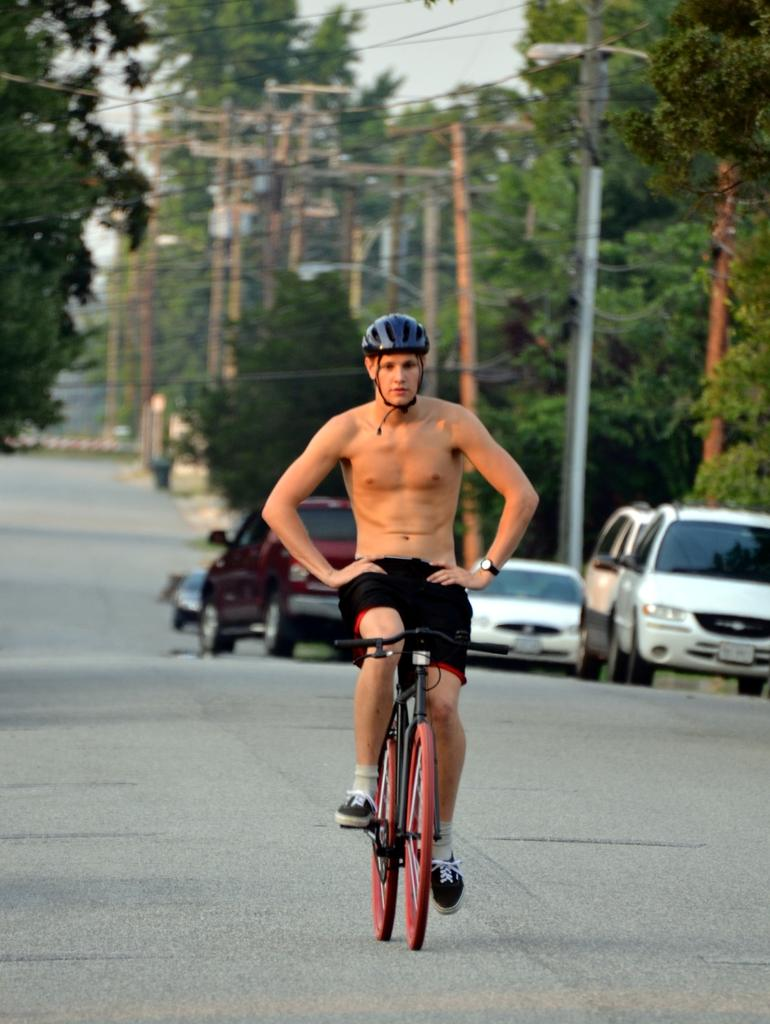What is the person in the image doing? The person is riding a bicycle on the road. What is behind the person riding the bicycle? There are vehicles behind the person. What structures can be seen in the image? Electric poles are visible in the image. What can be seen in the background of the image? There are trees and the sky visible in the background. Where is the mask located in the image? There is no mask present in the image. What type of downtown area can be seen in the image? The image does not depict a downtown area; it shows a person riding a bicycle on a road with trees and electric poles in the background. 